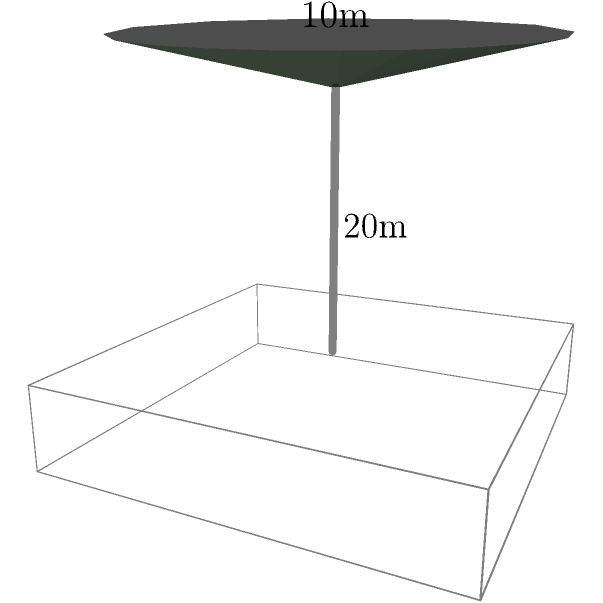A cylindrical smokestack from an industrial factory is releasing pollutants into the air. The smokestack has a height of 20 meters and a diameter of 2 meters. If the pollutants form a conical shape above the smokestack with an additional height of 10 meters, what is the total volume of the pollutant cloud in cubic meters? Assume the pollutant cloud includes the volume within the smokestack. To solve this problem, we need to calculate the volume of two shapes and add them together:

1. The volume of the cylindrical smokestack:
   $V_{cylinder} = \pi r^2 h$
   where $r$ is the radius (1 meter) and $h$ is the height (20 meters)
   $V_{cylinder} = \pi (1 \text{ m})^2 (20 \text{ m}) = 20\pi \text{ m}^3$

2. The volume of the conical shape above the smokestack:
   $V_{cone} = \frac{1}{3} \pi r^2 h$
   where $r$ is the radius of the base (1 meter) and $h$ is the height (10 meters)
   $V_{cone} = \frac{1}{3} \pi (1 \text{ m})^2 (10 \text{ m}) = \frac{10}{3}\pi \text{ m}^3$

3. Total volume:
   $V_{total} = V_{cylinder} + V_{cone}$
   $V_{total} = 20\pi \text{ m}^3 + \frac{10}{3}\pi \text{ m}^3$
   $V_{total} = (20 + \frac{10}{3})\pi \text{ m}^3$
   $V_{total} = \frac{70}{3}\pi \text{ m}^3$

4. Calculate the final value:
   $V_{total} = \frac{70}{3}\pi \text{ m}^3 \approx 73.30 \text{ m}^3$
Answer: 73.30 m³ 